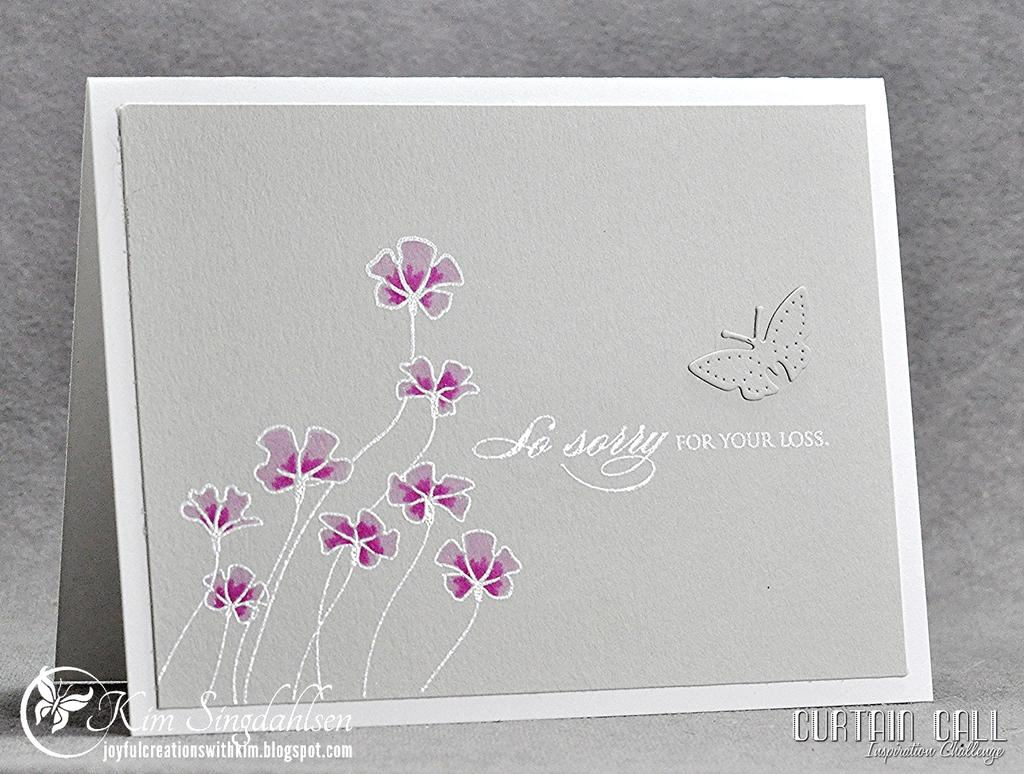What is present on the poster in the image? The poster contains text and images. Can you describe the watermarks in the image? There are watermarks on the bottom left and bottom right sides of the image. What type of cream is being used on the body in the image? There is no body or cream present in the image; it only contains a poster with text and images, along with watermarks. 